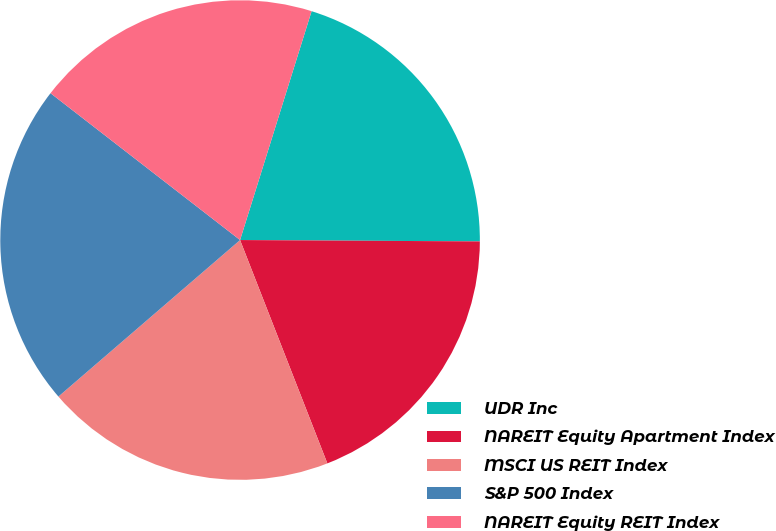Convert chart to OTSL. <chart><loc_0><loc_0><loc_500><loc_500><pie_chart><fcel>UDR Inc<fcel>NAREIT Equity Apartment Index<fcel>MSCI US REIT Index<fcel>S&P 500 Index<fcel>NAREIT Equity REIT Index<nl><fcel>20.27%<fcel>18.98%<fcel>19.61%<fcel>21.81%<fcel>19.33%<nl></chart> 